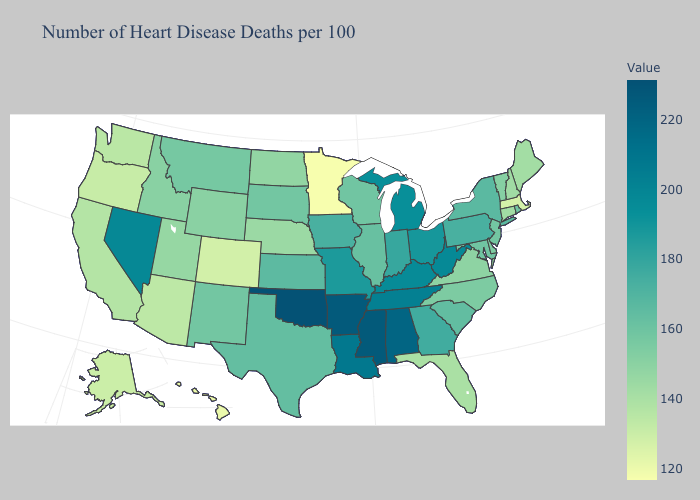Among the states that border Nebraska , does Wyoming have the lowest value?
Concise answer only. No. Which states hav the highest value in the Northeast?
Keep it brief. Pennsylvania. 